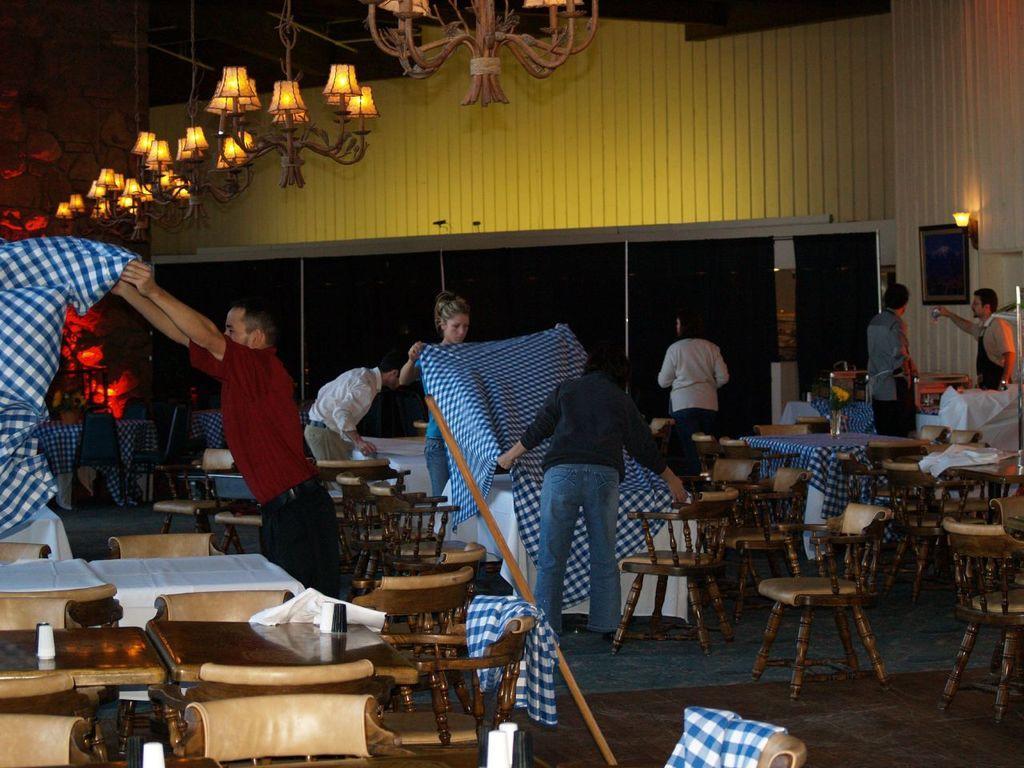Describe this image in one or two sentences. This image is clicked in a restaurant. There are lights on the top windows on the backside, there are so many tables and chairs. cLothes are placed on the table. There are so many people Standing and they are placing clothes on the tables. there is a light on the right side and photo frame too. 